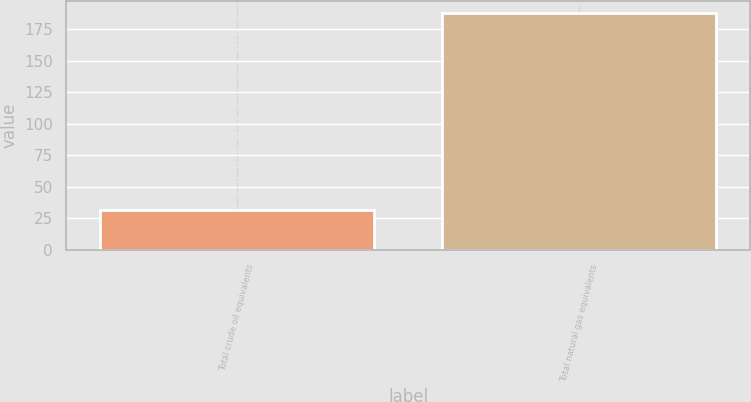Convert chart. <chart><loc_0><loc_0><loc_500><loc_500><bar_chart><fcel>Total crude oil equivalents<fcel>Total natural gas equivalents<nl><fcel>31.4<fcel>188.2<nl></chart> 